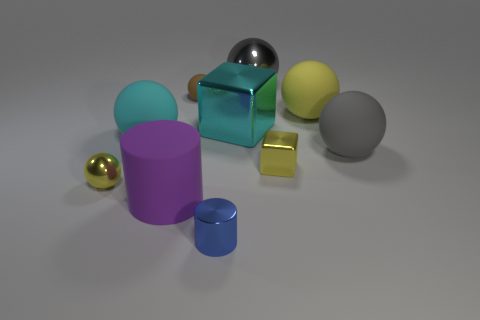Are there more big gray things that are behind the yellow block than cyan matte things that are right of the cyan sphere?
Provide a succinct answer. Yes. There is a big gray thing right of the large gray metallic ball; does it have the same shape as the yellow object on the left side of the large metallic block?
Your answer should be very brief. Yes. How many other things are the same size as the gray shiny object?
Give a very brief answer. 5. What is the size of the yellow block?
Your answer should be very brief. Small. Are the small cube that is behind the tiny metallic ball and the large cyan cube made of the same material?
Keep it short and to the point. Yes. What is the color of the large metal object that is the same shape as the big yellow matte thing?
Your answer should be very brief. Gray. Do the small ball that is on the left side of the brown rubber sphere and the tiny shiny cube have the same color?
Give a very brief answer. Yes. Are there any shiny spheres right of the large rubber cylinder?
Your answer should be compact. Yes. There is a small metallic thing that is both behind the small blue metallic cylinder and right of the big purple rubber cylinder; what color is it?
Your answer should be compact. Yellow. What is the shape of the metallic thing that is the same color as the tiny block?
Make the answer very short. Sphere. 